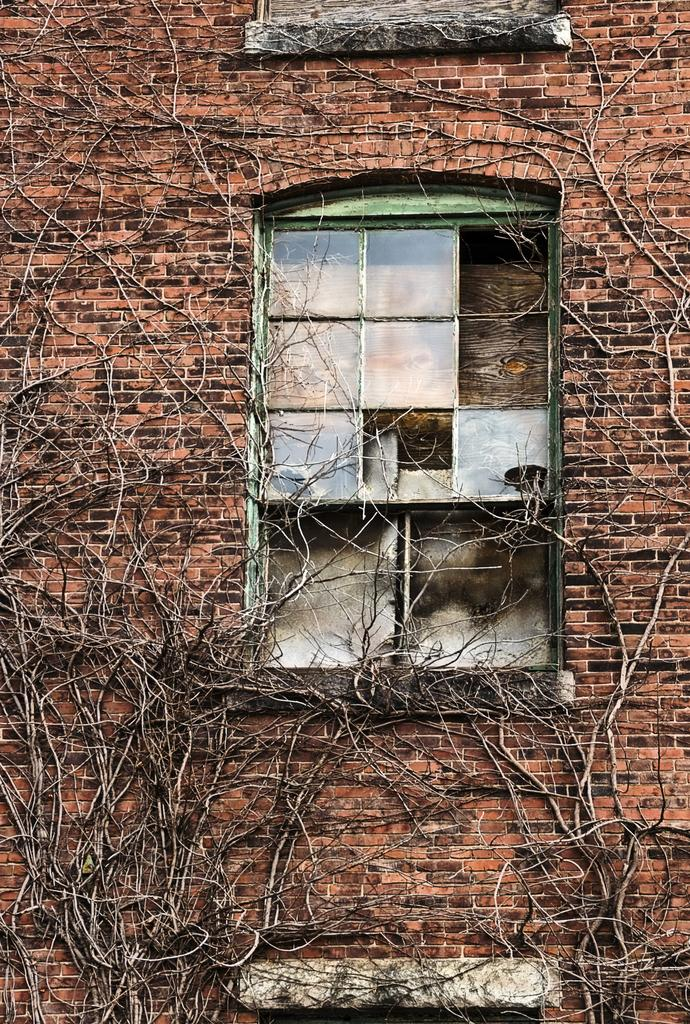What type of vegetation is growing on the wall in the image? There are creepers on the wall in the image. What can be seen through the windows on the wall? The wall has windows, but the image does not provide information about what can be seen through them. What type of joke is being told by the salt in the image? There is no salt or joke present in the image; it features creepers on a wall with windows. 